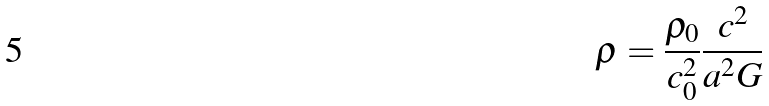Convert formula to latex. <formula><loc_0><loc_0><loc_500><loc_500>\rho = \frac { \rho _ { 0 } } { c _ { 0 } ^ { 2 } } \frac { c ^ { 2 } } { a ^ { 2 } G }</formula> 